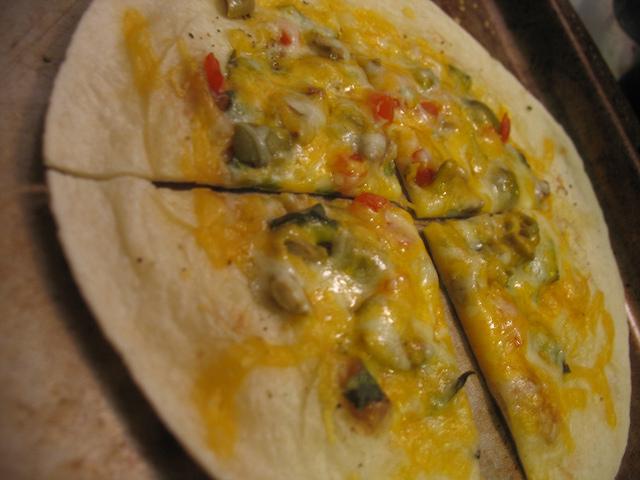What snack is on the table?
Concise answer only. Quesadilla. Would this be eaten for dinner?
Quick response, please. Yes. Could the snack be easily shared?
Be succinct. Yes. What snack is this?
Answer briefly. Quesadilla. Is the pizza full?
Short answer required. No. What are featured?
Be succinct. Pizza. 